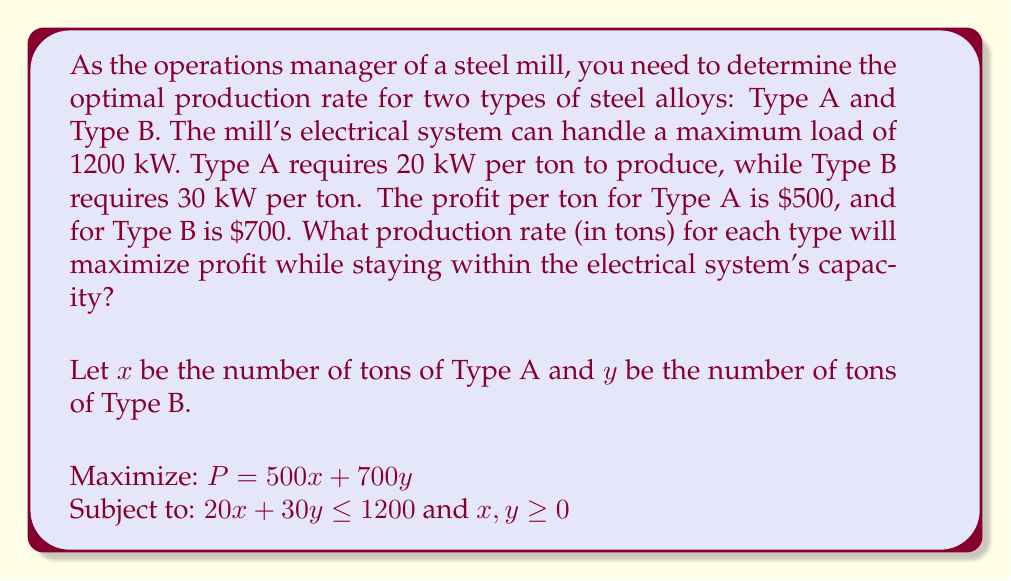Teach me how to tackle this problem. To solve this problem, we'll use linear programming techniques:

1) First, let's graph the constraint:
   $$20x + 30y = 1200$$
   
   This line intersects the axes at (60, 0) and (0, 40).

2) The feasible region is the area below this line in the first quadrant.

3) The objective function is $P = 500x + 700y$. We need to find where this line last intersects the feasible region as we increase P.

4) The optimal solution will be at one of the corner points of the feasible region. These are:
   (0, 0), (60, 0), (0, 40), and the intersection of $20x + 30y = 1200$ with $y = 0$ or $x = 0$.

5) Let's find the intersection point:
   $$20x + 30y = 1200$$
   $$20x + 30y = 1200$$
   $$2x + 3y = 120$$
   
   If $y = 0$, then $x = 60$
   If $x = 0$, then $y = 40$
   
   Solving simultaneously:
   $$2x + 3y = 120$$
   $$2x = 120 - 3y$$
   $$x = 60 - 1.5y$$
   
   Substituting into $20x + 30y = 1200$:
   $$20(60 - 1.5y) + 30y = 1200$$
   $$1200 - 30y + 30y = 1200$$
   $$1200 = 1200$$
   
   This confirms that (60, 0) and (0, 40) are the only integer solutions.

6) Now, let's evaluate the profit at each point:
   At (0, 0): $P = 0$
   At (60, 0): $P = 500(60) + 700(0) = 30,000$
   At (0, 40): $P = 500(0) + 700(40) = 28,000$

7) The maximum profit occurs at (60, 0), which means producing 60 tons of Type A and 0 tons of Type B.
Answer: 60 tons of Type A, 0 tons of Type B 